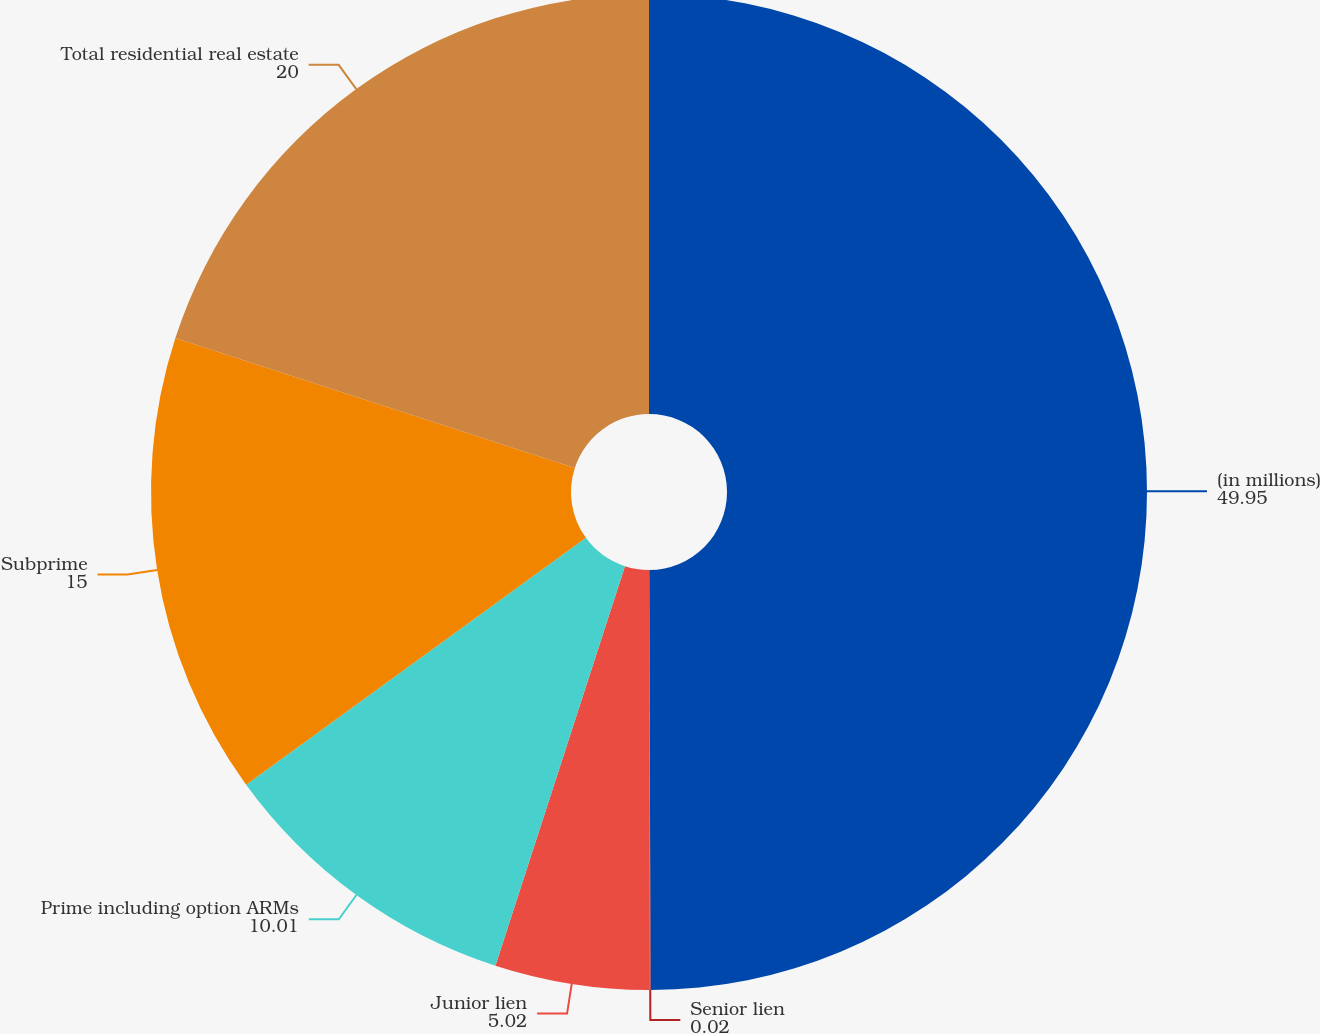<chart> <loc_0><loc_0><loc_500><loc_500><pie_chart><fcel>(in millions)<fcel>Senior lien<fcel>Junior lien<fcel>Prime including option ARMs<fcel>Subprime<fcel>Total residential real estate<nl><fcel>49.95%<fcel>0.02%<fcel>5.02%<fcel>10.01%<fcel>15.0%<fcel>20.0%<nl></chart> 